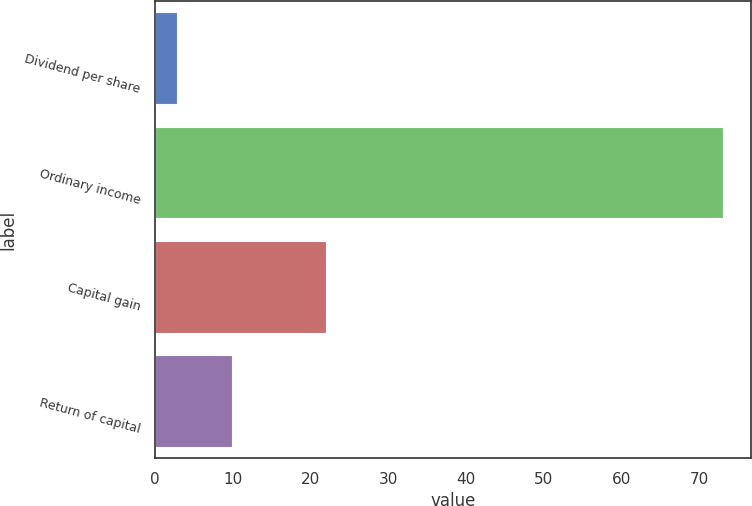Convert chart to OTSL. <chart><loc_0><loc_0><loc_500><loc_500><bar_chart><fcel>Dividend per share<fcel>Ordinary income<fcel>Capital gain<fcel>Return of capital<nl><fcel>2.9<fcel>73<fcel>22<fcel>9.91<nl></chart> 